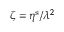Convert formula to latex. <formula><loc_0><loc_0><loc_500><loc_500>\zeta = \eta ^ { s } / \lambda ^ { 2 }</formula> 